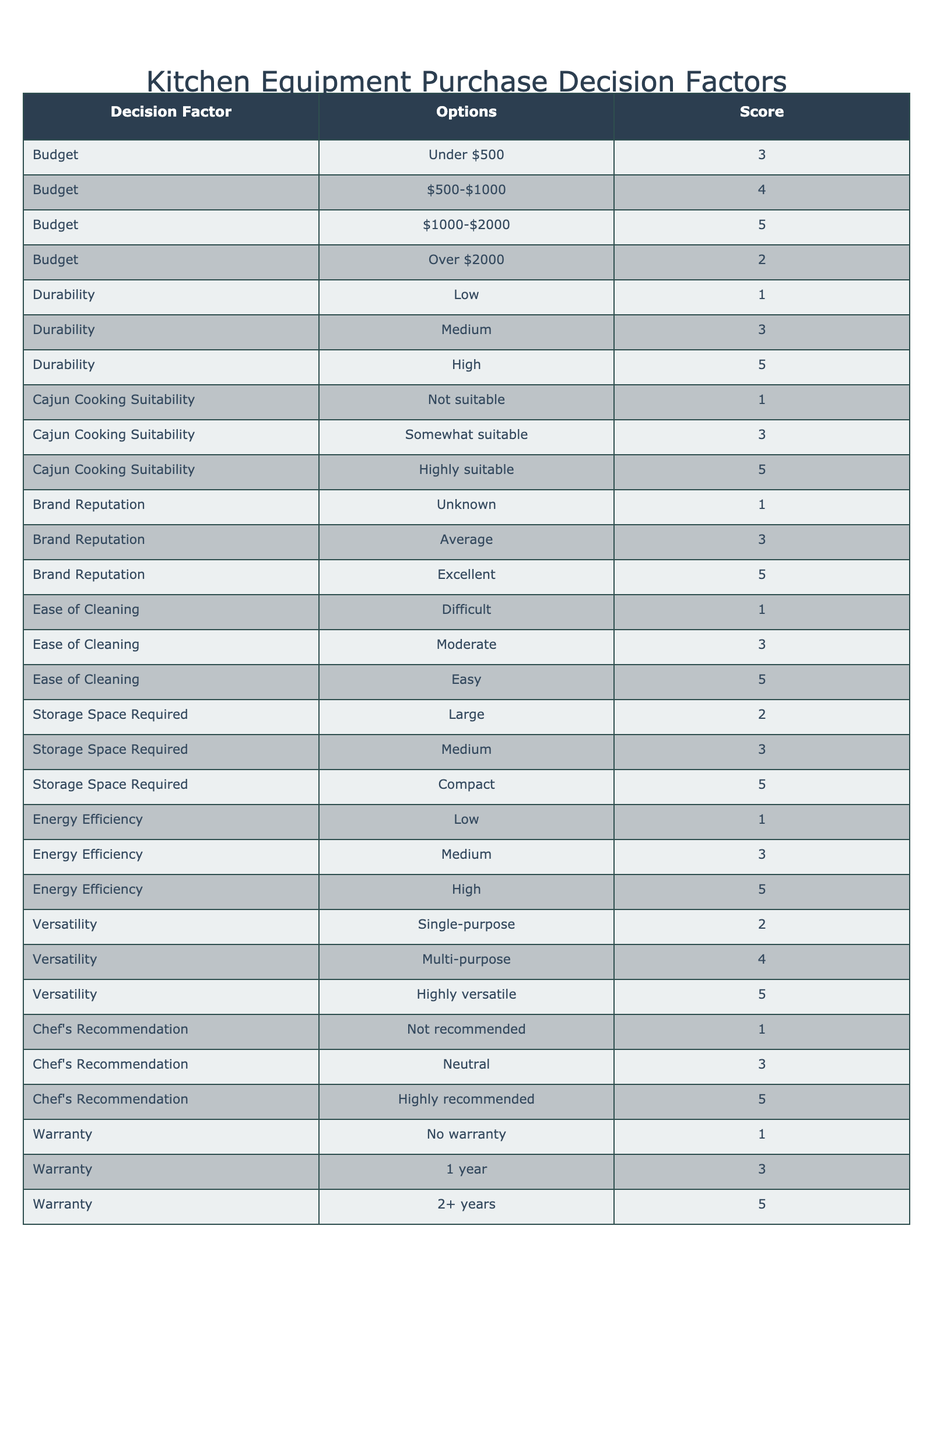What is the highest score for Cajun Cooking Suitability? The highest score for Cajun Cooking Suitability is found in the row with "Highly suitable," which has a score of 5.
Answer: 5 What is the average score for durability? To find the average score for durability, we consider the scores for Low (1), Medium (3), and High (5). The sum is 1 + 3 + 5 = 9, and there are 3 options, so the average is 9/3 = 3.
Answer: 3 Is a warranty of 2+ years considered a factor? Yes, a warranty of 2+ years is indeed one of the options presented in the table under the Warranty decision factor.
Answer: Yes What is the minimum score for Energy Efficiency? The minimum score for Energy Efficiency is found in the row with "Low," which has a score of 1.
Answer: 1 If we compare the scores for Budget below $1000, which option is better? The options for Budget below $1000 include Under $500 (3) and $500-$1000 (4). The better option is $500-$1000 with a score of 4.
Answer: $500-$1000 What is the total score for all options under the Ease of Cleaning category? The total score for Ease of Cleaning options (Difficult: 1, Moderate: 3, Easy: 5) is 1 + 3 + 5 = 9.
Answer: 9 Is a purchase with "Average" Brand Reputation likely a good choice? A purchase with "Average" Brand Reputation scores 3, which is middle of the range but not excellent. It's not particularly favorable compared to options with higher scores.
Answer: No What is the score difference between "Highly versatile" and "Single-purpose" in the Versatility category? In the Versatility category, "Highly versatile" has a score of 5 and "Single-purpose" has a score of 2. The difference is 5 - 2 = 3.
Answer: 3 Which option has the lowest score in the Storage Space Required factor? The option with the lowest score in the Storage Space Required factor is "Large," which has a score of 2.
Answer: 2 